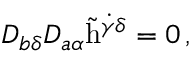<formula> <loc_0><loc_0><loc_500><loc_500>D _ { b \delta } D _ { a \alpha } \tilde { h } ^ { \dot { \gamma } \delta } = 0 \, ,</formula> 